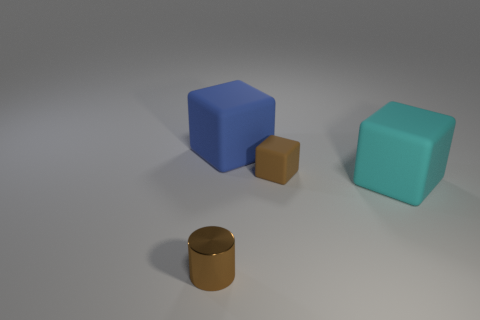Could you describe the surface on which the objects are placed? The objects are placed on a smooth, matte surface that appears to be evenly lit, with a neutral gray tone. The lack of texture and the even lighting create a minimalistic aesthetic and provides a clear contrast to the objects, emphasizing their shapes and colors.  Do these objects look like they are in motion or stationary? The objects appear to be stationary. There are no signs of motion blur or tilted angles that would imply movement. Each object casts a sharp, distinct shadow that further suggests they are at rest. 